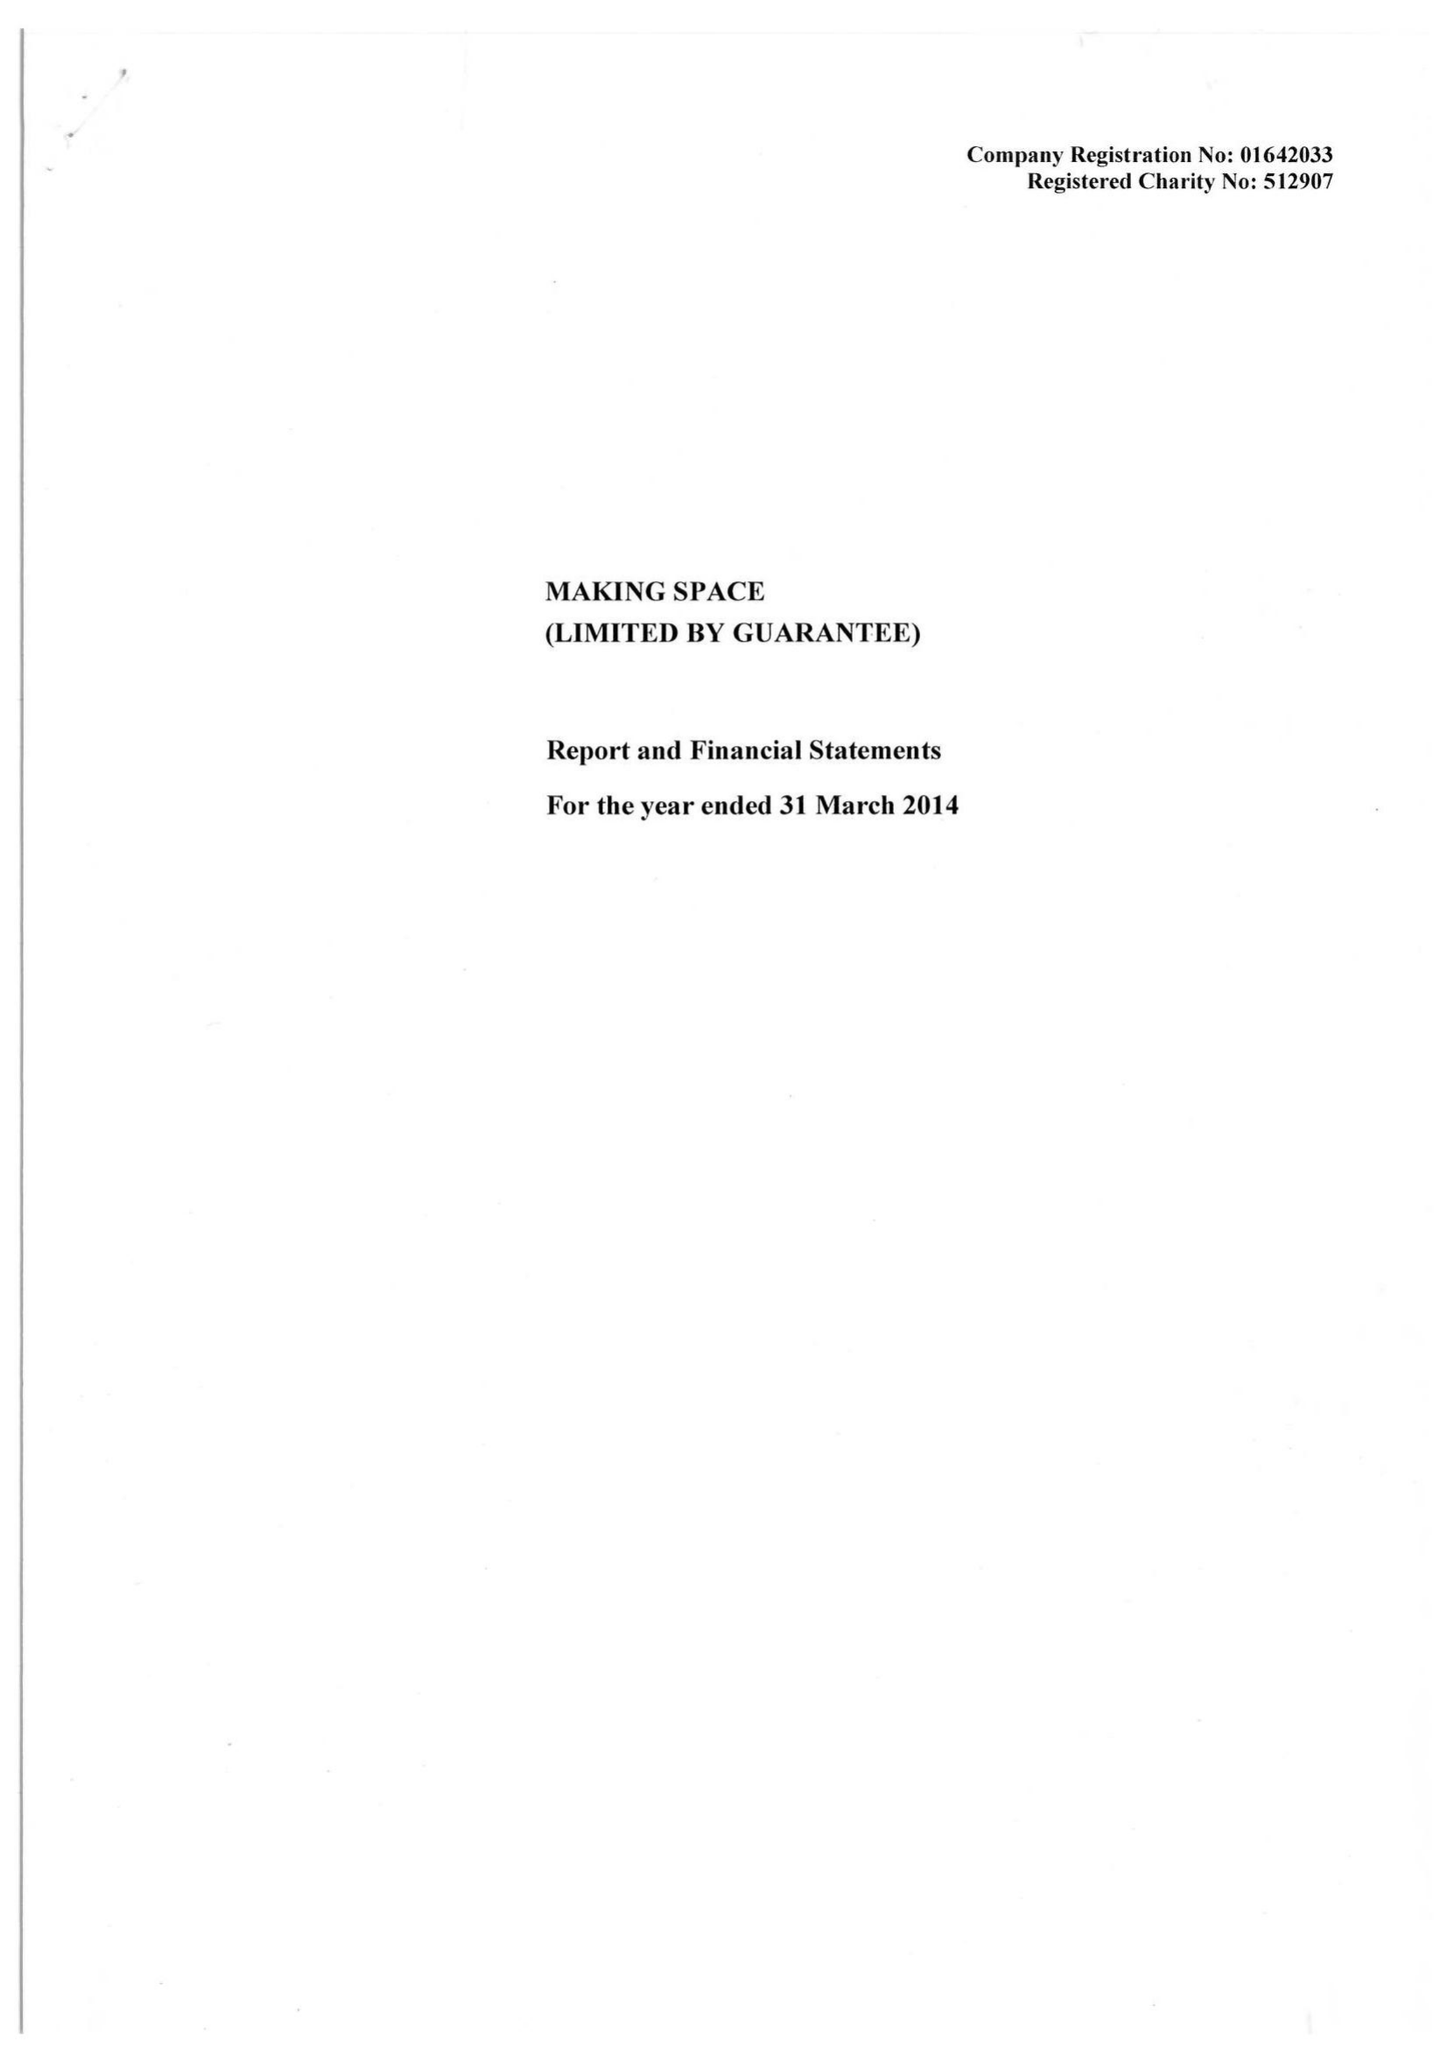What is the value for the address__postcode?
Answer the question using a single word or phrase. WA2 7JB 